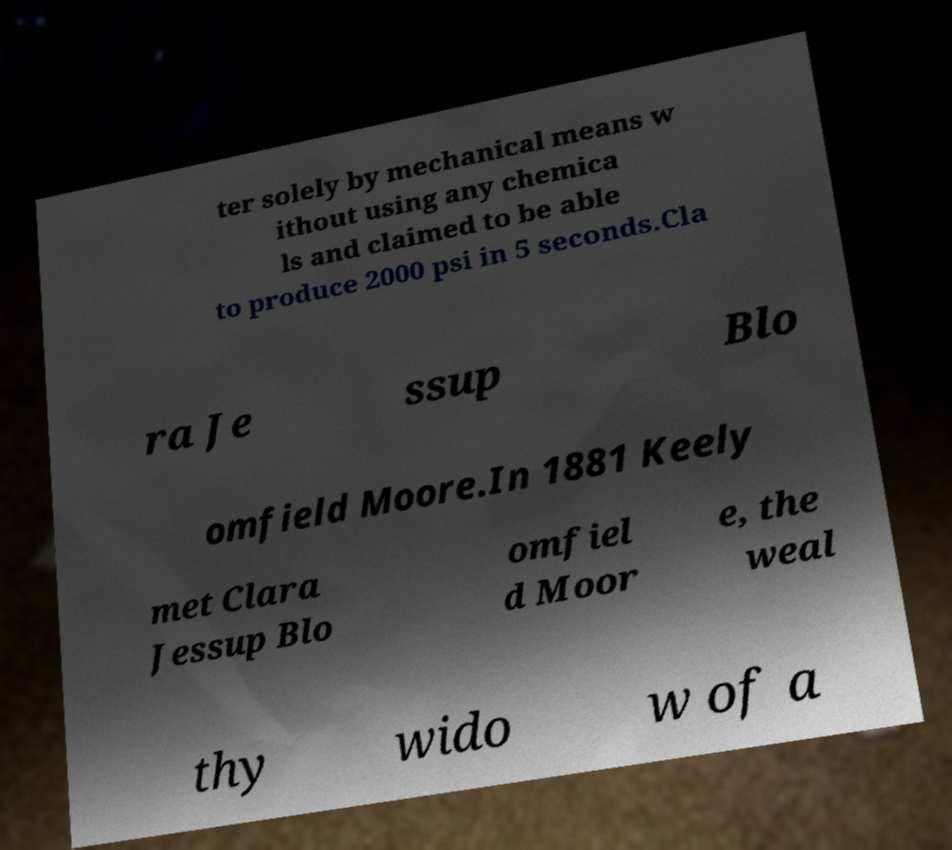Could you extract and type out the text from this image? ter solely by mechanical means w ithout using any chemica ls and claimed to be able to produce 2000 psi in 5 seconds.Cla ra Je ssup Blo omfield Moore.In 1881 Keely met Clara Jessup Blo omfiel d Moor e, the weal thy wido w of a 